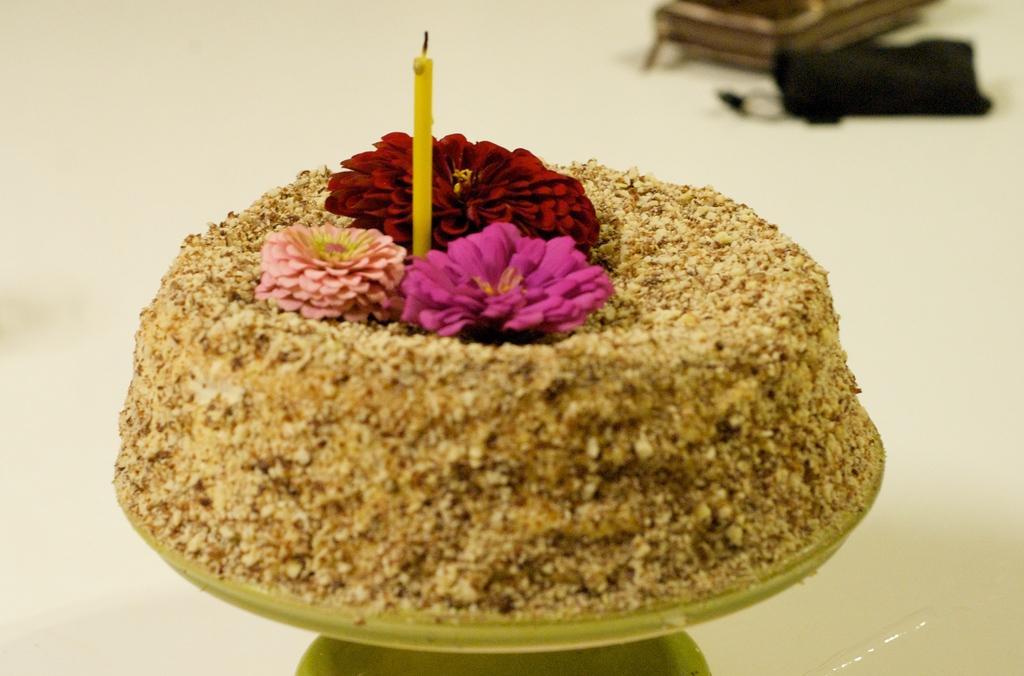Could you give a brief overview of what you see in this image? In this image, we can see a food item with some flowers and a candle is placed on an object. We can see the ground with some objects. 